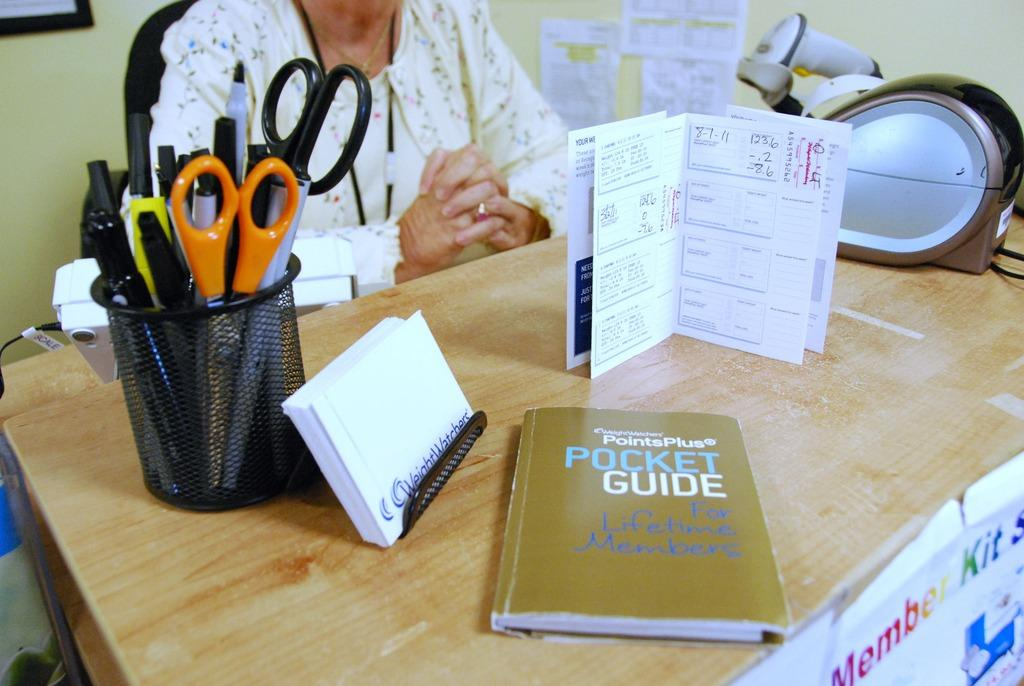<image>
Give a short and clear explanation of the subsequent image. A pocket guide is on a desk with scissors. 